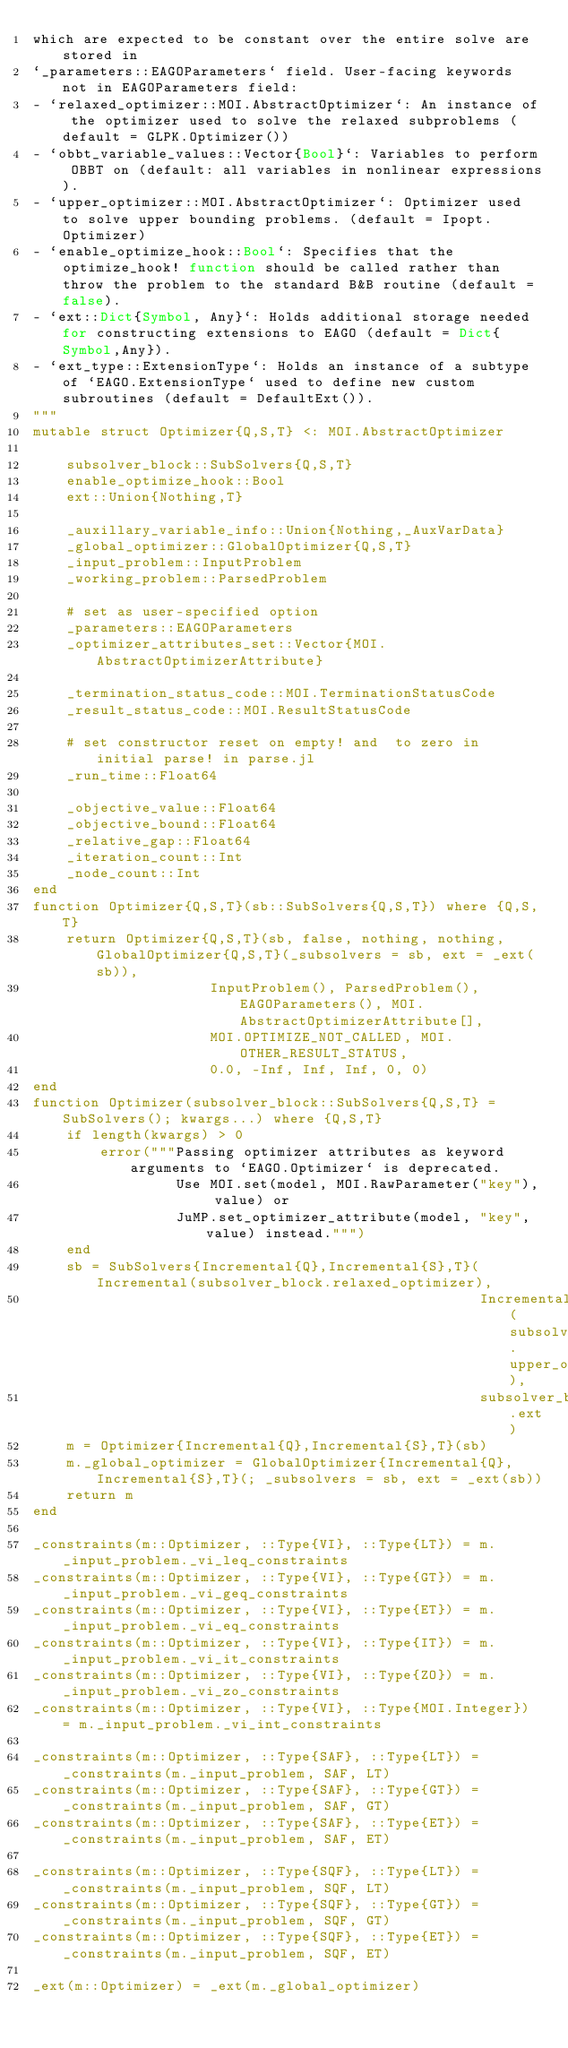Convert code to text. <code><loc_0><loc_0><loc_500><loc_500><_Julia_>which are expected to be constant over the entire solve are stored in
`_parameters::EAGOParameters` field. User-facing keywords not in EAGOParameters field:
- `relaxed_optimizer::MOI.AbstractOptimizer`: An instance of the optimizer used to solve the relaxed subproblems (default = GLPK.Optimizer())
- `obbt_variable_values::Vector{Bool}`: Variables to perform OBBT on (default: all variables in nonlinear expressions).
- `upper_optimizer::MOI.AbstractOptimizer`: Optimizer used to solve upper bounding problems. (default = Ipopt.Optimizer)
- `enable_optimize_hook::Bool`: Specifies that the optimize_hook! function should be called rather than throw the problem to the standard B&B routine (default = false).
- `ext::Dict{Symbol, Any}`: Holds additional storage needed for constructing extensions to EAGO (default = Dict{Symbol,Any}).
- `ext_type::ExtensionType`: Holds an instance of a subtype of `EAGO.ExtensionType` used to define new custom subroutines (default = DefaultExt()).
"""
mutable struct Optimizer{Q,S,T} <: MOI.AbstractOptimizer

    subsolver_block::SubSolvers{Q,S,T}
    enable_optimize_hook::Bool
    ext::Union{Nothing,T}
  
    _auxillary_variable_info::Union{Nothing,_AuxVarData}
    _global_optimizer::GlobalOptimizer{Q,S,T}
    _input_problem::InputProblem
    _working_problem::ParsedProblem

    # set as user-specified option
    _parameters::EAGOParameters
    _optimizer_attributes_set::Vector{MOI.AbstractOptimizerAttribute}

    _termination_status_code::MOI.TerminationStatusCode
    _result_status_code::MOI.ResultStatusCode

    # set constructor reset on empty! and  to zero in initial parse! in parse.jl
    _run_time::Float64

    _objective_value::Float64
    _objective_bound::Float64
    _relative_gap::Float64
    _iteration_count::Int
    _node_count::Int
end
function Optimizer{Q,S,T}(sb::SubSolvers{Q,S,T}) where {Q,S,T}
    return Optimizer{Q,S,T}(sb, false, nothing, nothing, GlobalOptimizer{Q,S,T}(_subsolvers = sb, ext = _ext(sb)),
                     InputProblem(), ParsedProblem(), EAGOParameters(), MOI.AbstractOptimizerAttribute[],
                     MOI.OPTIMIZE_NOT_CALLED, MOI.OTHER_RESULT_STATUS,
                     0.0, -Inf, Inf, Inf, 0, 0)
end
function Optimizer(subsolver_block::SubSolvers{Q,S,T} = SubSolvers(); kwargs...) where {Q,S,T}
    if length(kwargs) > 0
        error("""Passing optimizer attributes as keyword arguments to `EAGO.Optimizer` is deprecated. 
                 Use MOI.set(model, MOI.RawParameter("key"), value) or 
                 JuMP.set_optimizer_attribute(model, "key", value) instead.""")
    end
    sb = SubSolvers{Incremental{Q},Incremental{S},T}(Incremental(subsolver_block.relaxed_optimizer), 
                                                     Incremental(subsolver_block.upper_optimizer),  
                                                     subsolver_block.ext)
    m = Optimizer{Incremental{Q},Incremental{S},T}(sb)
    m._global_optimizer = GlobalOptimizer{Incremental{Q},Incremental{S},T}(; _subsolvers = sb, ext = _ext(sb))
    return m
end

_constraints(m::Optimizer, ::Type{VI}, ::Type{LT}) = m._input_problem._vi_leq_constraints
_constraints(m::Optimizer, ::Type{VI}, ::Type{GT}) = m._input_problem._vi_geq_constraints
_constraints(m::Optimizer, ::Type{VI}, ::Type{ET}) = m._input_problem._vi_eq_constraints
_constraints(m::Optimizer, ::Type{VI}, ::Type{IT}) = m._input_problem._vi_it_constraints
_constraints(m::Optimizer, ::Type{VI}, ::Type{ZO}) = m._input_problem._vi_zo_constraints
_constraints(m::Optimizer, ::Type{VI}, ::Type{MOI.Integer}) = m._input_problem._vi_int_constraints

_constraints(m::Optimizer, ::Type{SAF}, ::Type{LT}) = _constraints(m._input_problem, SAF, LT)
_constraints(m::Optimizer, ::Type{SAF}, ::Type{GT}) = _constraints(m._input_problem, SAF, GT)
_constraints(m::Optimizer, ::Type{SAF}, ::Type{ET}) = _constraints(m._input_problem, SAF, ET)

_constraints(m::Optimizer, ::Type{SQF}, ::Type{LT}) = _constraints(m._input_problem, SQF, LT)
_constraints(m::Optimizer, ::Type{SQF}, ::Type{GT}) = _constraints(m._input_problem, SQF, GT)
_constraints(m::Optimizer, ::Type{SQF}, ::Type{ET}) = _constraints(m._input_problem, SQF, ET)

_ext(m::Optimizer) = _ext(m._global_optimizer)</code> 